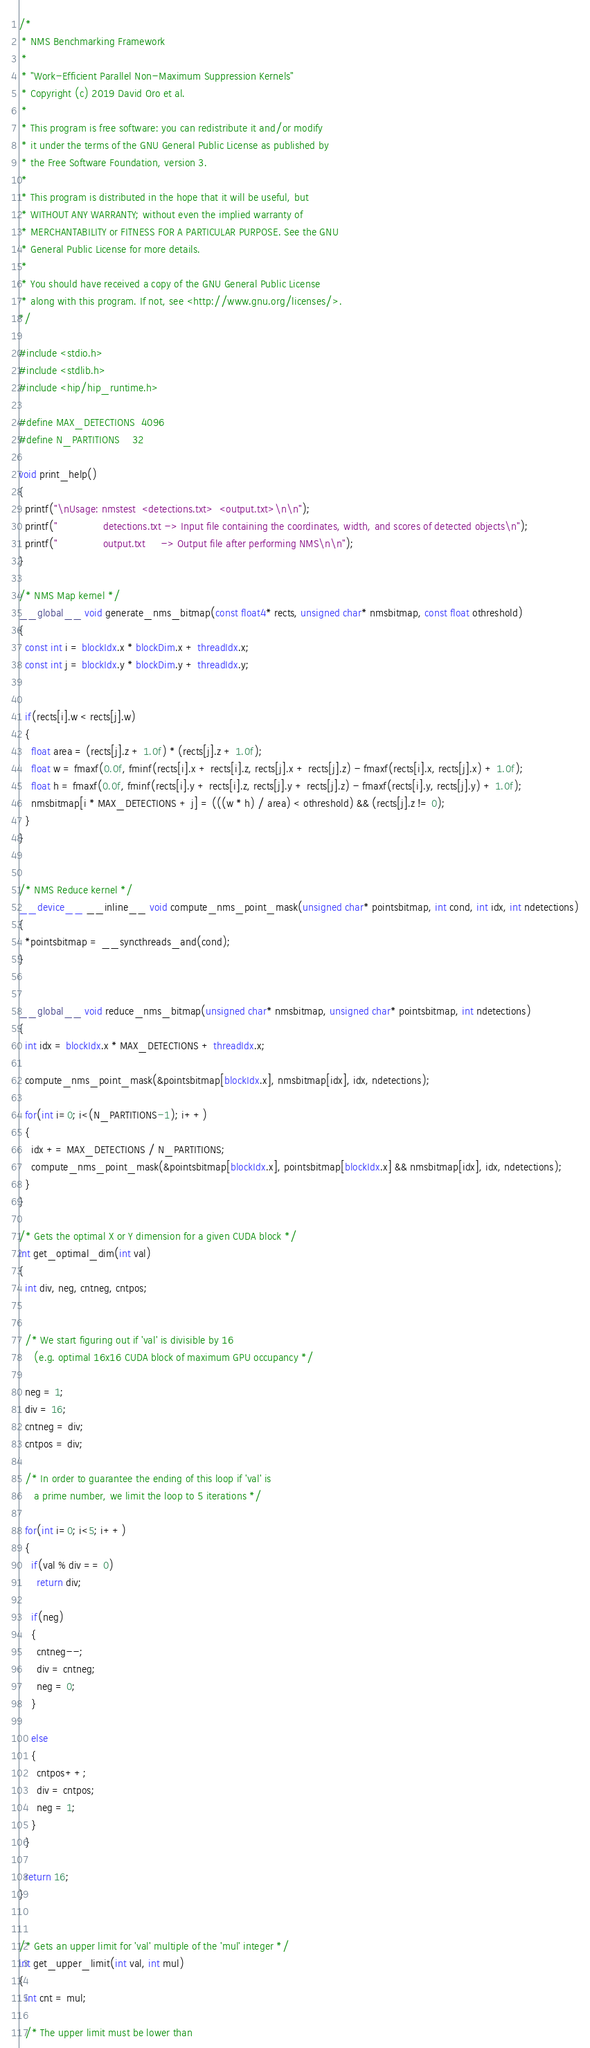Convert code to text. <code><loc_0><loc_0><loc_500><loc_500><_Cuda_>/* 
 * NMS Benchmarking Framework
 *
 * "Work-Efficient Parallel Non-Maximum Suppression Kernels"
 * Copyright (c) 2019 David Oro et al.
 * 
 * This program is free software: you can redistribute it and/or modify  
 * it under the terms of the GNU General Public License as published by  
 * the Free Software Foundation, version 3.
 *
 * This program is distributed in the hope that it will be useful, but 
 * WITHOUT ANY WARRANTY; without even the implied warranty of 
 * MERCHANTABILITY or FITNESS FOR A PARTICULAR PURPOSE. See the GNU 
 * General Public License for more details.
 *
 * You should have received a copy of the GNU General Public License 
 * along with this program. If not, see <http://www.gnu.org/licenses/>.
*/

#include <stdio.h>
#include <stdlib.h>
#include <hip/hip_runtime.h>

#define MAX_DETECTIONS  4096
#define N_PARTITIONS    32

void print_help()
{
  printf("\nUsage: nmstest  <detections.txt>  <output.txt>\n\n");
  printf("               detections.txt -> Input file containing the coordinates, width, and scores of detected objects\n");
  printf("               output.txt     -> Output file after performing NMS\n\n");
}

/* NMS Map kernel */
__global__ void generate_nms_bitmap(const float4* rects, unsigned char* nmsbitmap, const float othreshold)
{
  const int i = blockIdx.x * blockDim.x + threadIdx.x;
  const int j = blockIdx.y * blockDim.y + threadIdx.y;


  if(rects[i].w < rects[j].w)
  {
    float area = (rects[j].z + 1.0f) * (rects[j].z + 1.0f);
    float w = fmaxf(0.0f, fminf(rects[i].x + rects[i].z, rects[j].x + rects[j].z) - fmaxf(rects[i].x, rects[j].x) + 1.0f);
    float h = fmaxf(0.0f, fminf(rects[i].y + rects[i].z, rects[j].y + rects[j].z) - fmaxf(rects[i].y, rects[j].y) + 1.0f);
    nmsbitmap[i * MAX_DETECTIONS + j] = (((w * h) / area) < othreshold) && (rects[j].z != 0);
  }
}


/* NMS Reduce kernel */
__device__ __inline__ void compute_nms_point_mask(unsigned char* pointsbitmap, int cond, int idx, int ndetections)
{
  *pointsbitmap = __syncthreads_and(cond);
}


__global__ void reduce_nms_bitmap(unsigned char* nmsbitmap, unsigned char* pointsbitmap, int ndetections)
{
  int idx = blockIdx.x * MAX_DETECTIONS + threadIdx.x;

  compute_nms_point_mask(&pointsbitmap[blockIdx.x], nmsbitmap[idx], idx, ndetections);

  for(int i=0; i<(N_PARTITIONS-1); i++)
  {
    idx += MAX_DETECTIONS / N_PARTITIONS;
    compute_nms_point_mask(&pointsbitmap[blockIdx.x], pointsbitmap[blockIdx.x] && nmsbitmap[idx], idx, ndetections);
  }
} 

/* Gets the optimal X or Y dimension for a given CUDA block */
int get_optimal_dim(int val)
{
  int div, neg, cntneg, cntpos;


  /* We start figuring out if 'val' is divisible by 16 
     (e.g. optimal 16x16 CUDA block of maximum GPU occupancy */

  neg = 1;
  div = 16;
  cntneg = div;
  cntpos = div;

  /* In order to guarantee the ending of this loop if 'val' is 
     a prime number, we limit the loop to 5 iterations */

  for(int i=0; i<5; i++)
  {
    if(val % div == 0)
      return div;

    if(neg)
    {
      cntneg--;
      div = cntneg;
      neg = 0;
    }

    else
    {
      cntpos++;
      div = cntpos;
      neg = 1;
    }
  }

  return 16;
}


/* Gets an upper limit for 'val' multiple of the 'mul' integer */
int get_upper_limit(int val, int mul)
{
  int cnt = mul;

  /* The upper limit must be lower than</code> 